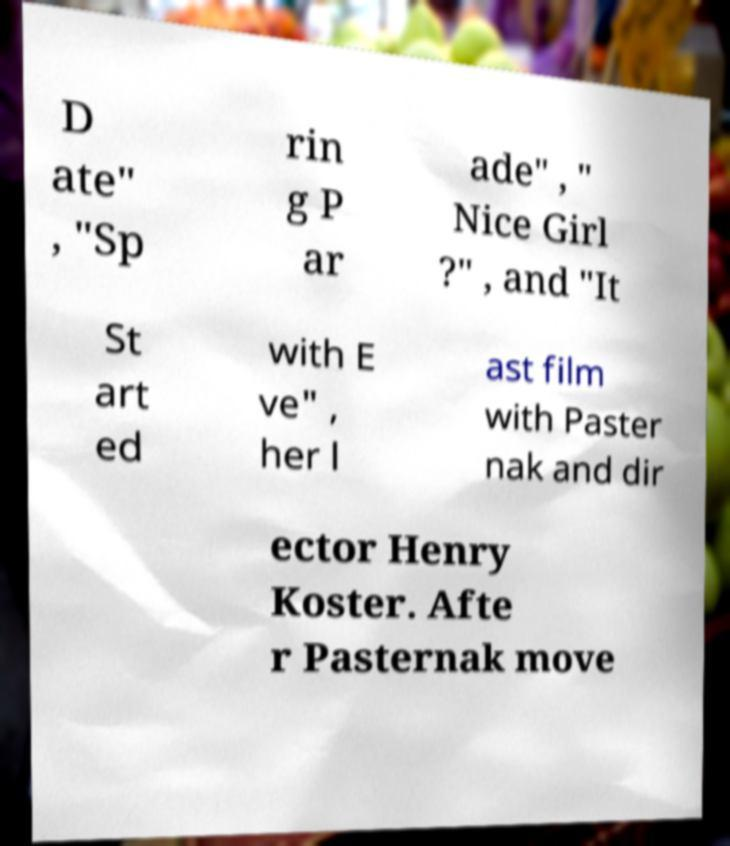Can you read and provide the text displayed in the image?This photo seems to have some interesting text. Can you extract and type it out for me? D ate" , "Sp rin g P ar ade" , " Nice Girl ?" , and "It St art ed with E ve" , her l ast film with Paster nak and dir ector Henry Koster. Afte r Pasternak move 